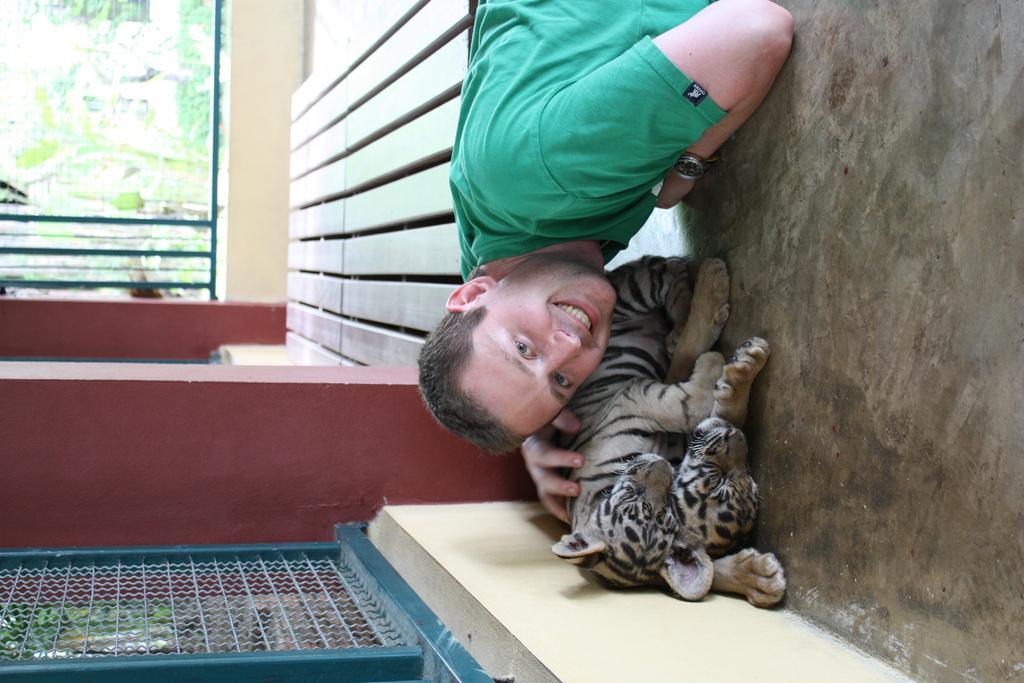Could you give a brief overview of what you see in this image? In this picture I can see a man and I can see couple of tiger cubs and I can see plants, metal fence and I can see metal rods. 